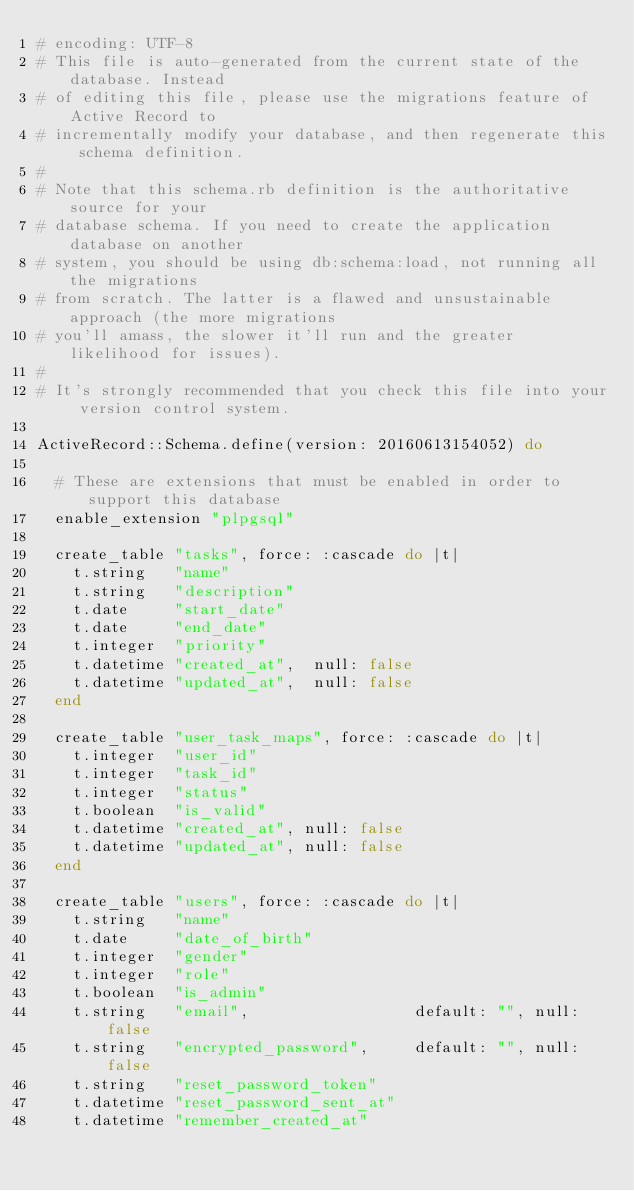Convert code to text. <code><loc_0><loc_0><loc_500><loc_500><_Ruby_># encoding: UTF-8
# This file is auto-generated from the current state of the database. Instead
# of editing this file, please use the migrations feature of Active Record to
# incrementally modify your database, and then regenerate this schema definition.
#
# Note that this schema.rb definition is the authoritative source for your
# database schema. If you need to create the application database on another
# system, you should be using db:schema:load, not running all the migrations
# from scratch. The latter is a flawed and unsustainable approach (the more migrations
# you'll amass, the slower it'll run and the greater likelihood for issues).
#
# It's strongly recommended that you check this file into your version control system.

ActiveRecord::Schema.define(version: 20160613154052) do

  # These are extensions that must be enabled in order to support this database
  enable_extension "plpgsql"

  create_table "tasks", force: :cascade do |t|
    t.string   "name"
    t.string   "description"
    t.date     "start_date"
    t.date     "end_date"
    t.integer  "priority"
    t.datetime "created_at",  null: false
    t.datetime "updated_at",  null: false
  end

  create_table "user_task_maps", force: :cascade do |t|
    t.integer  "user_id"
    t.integer  "task_id"
    t.integer  "status"
    t.boolean  "is_valid"
    t.datetime "created_at", null: false
    t.datetime "updated_at", null: false
  end

  create_table "users", force: :cascade do |t|
    t.string   "name"
    t.date     "date_of_birth"
    t.integer  "gender"
    t.integer  "role"
    t.boolean  "is_admin"
    t.string   "email",                  default: "", null: false
    t.string   "encrypted_password",     default: "", null: false
    t.string   "reset_password_token"
    t.datetime "reset_password_sent_at"
    t.datetime "remember_created_at"</code> 